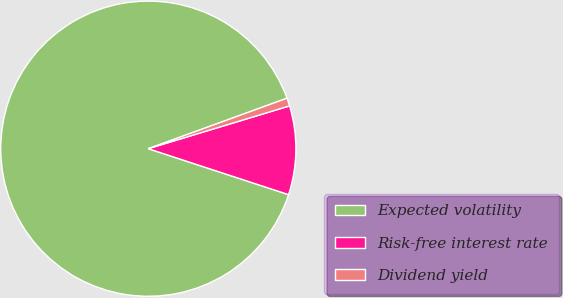Convert chart. <chart><loc_0><loc_0><loc_500><loc_500><pie_chart><fcel>Expected volatility<fcel>Risk-free interest rate<fcel>Dividend yield<nl><fcel>89.41%<fcel>9.72%<fcel>0.87%<nl></chart> 